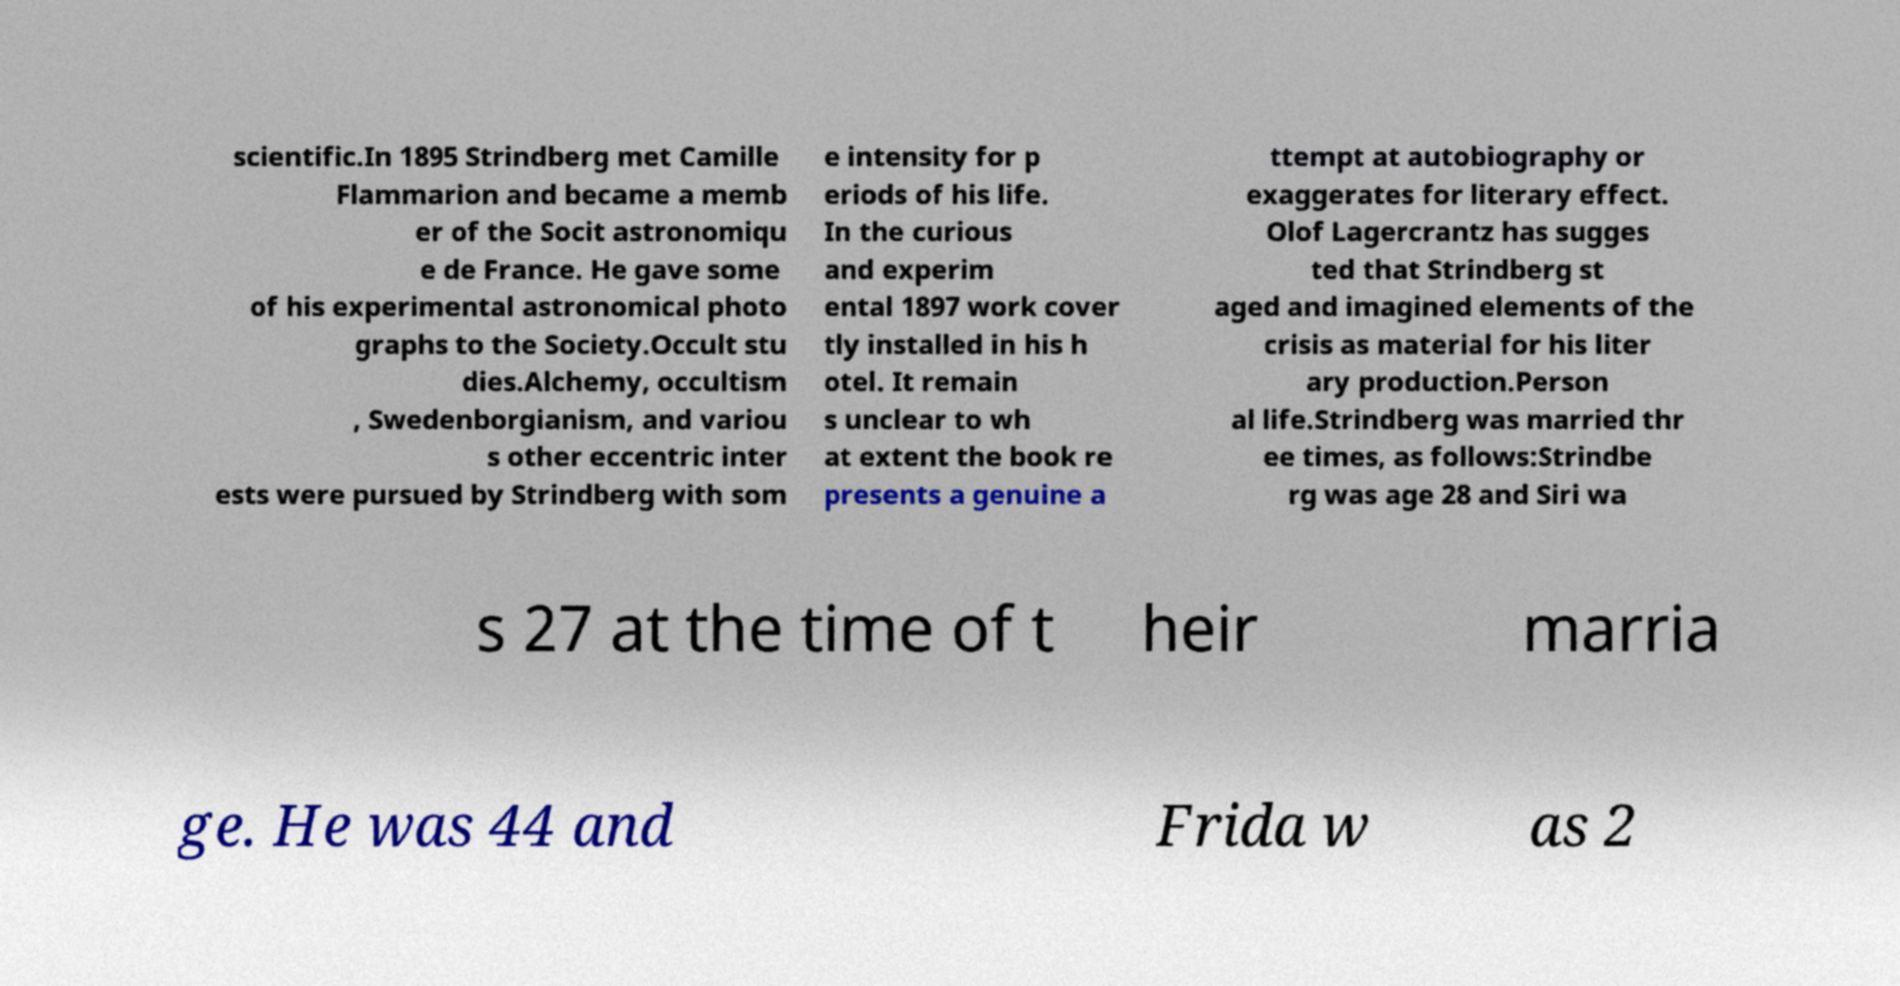Please read and relay the text visible in this image. What does it say? scientific.In 1895 Strindberg met Camille Flammarion and became a memb er of the Socit astronomiqu e de France. He gave some of his experimental astronomical photo graphs to the Society.Occult stu dies.Alchemy, occultism , Swedenborgianism, and variou s other eccentric inter ests were pursued by Strindberg with som e intensity for p eriods of his life. In the curious and experim ental 1897 work cover tly installed in his h otel. It remain s unclear to wh at extent the book re presents a genuine a ttempt at autobiography or exaggerates for literary effect. Olof Lagercrantz has sugges ted that Strindberg st aged and imagined elements of the crisis as material for his liter ary production.Person al life.Strindberg was married thr ee times, as follows:Strindbe rg was age 28 and Siri wa s 27 at the time of t heir marria ge. He was 44 and Frida w as 2 